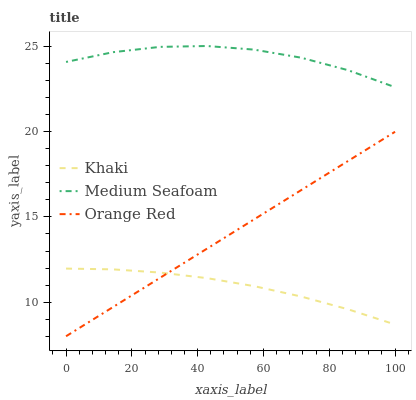Does Orange Red have the minimum area under the curve?
Answer yes or no. No. Does Orange Red have the maximum area under the curve?
Answer yes or no. No. Is Medium Seafoam the smoothest?
Answer yes or no. No. Is Orange Red the roughest?
Answer yes or no. No. Does Medium Seafoam have the lowest value?
Answer yes or no. No. Does Orange Red have the highest value?
Answer yes or no. No. Is Orange Red less than Medium Seafoam?
Answer yes or no. Yes. Is Medium Seafoam greater than Khaki?
Answer yes or no. Yes. Does Orange Red intersect Medium Seafoam?
Answer yes or no. No. 